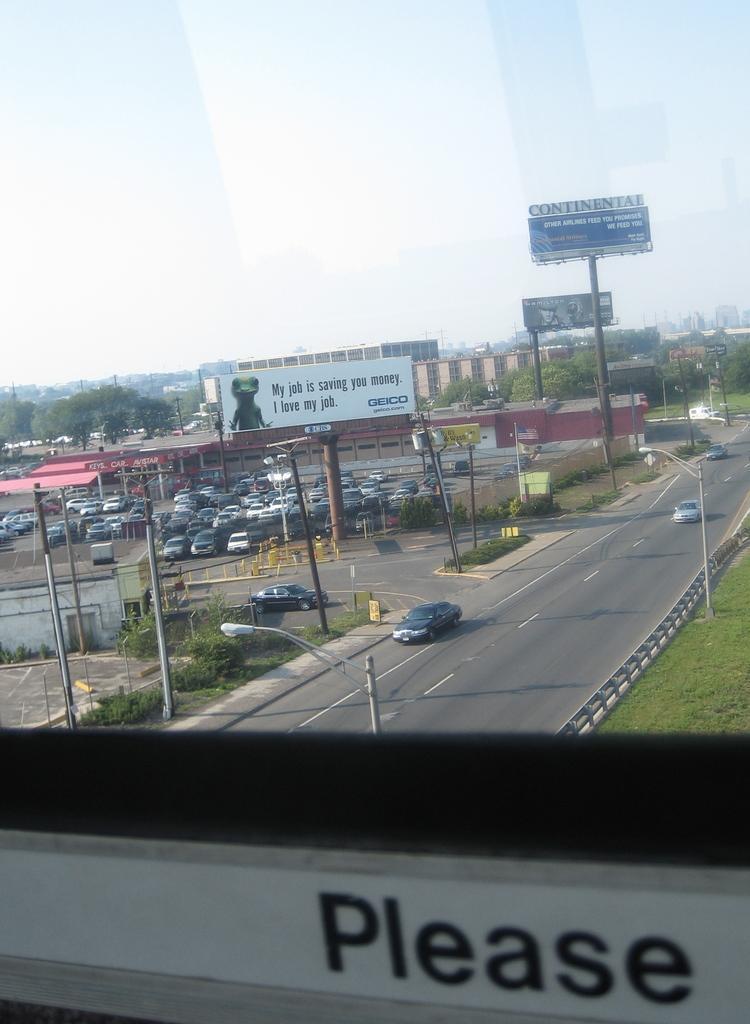Describe this image in one or two sentences. In this picture, we can see a view from the glass window, and we can see some text on the bottom side of the picture, we can see the road, a few vehicles, ground with grass, poles, trees, sky, sheds, buildings, posters with some text, lights. 